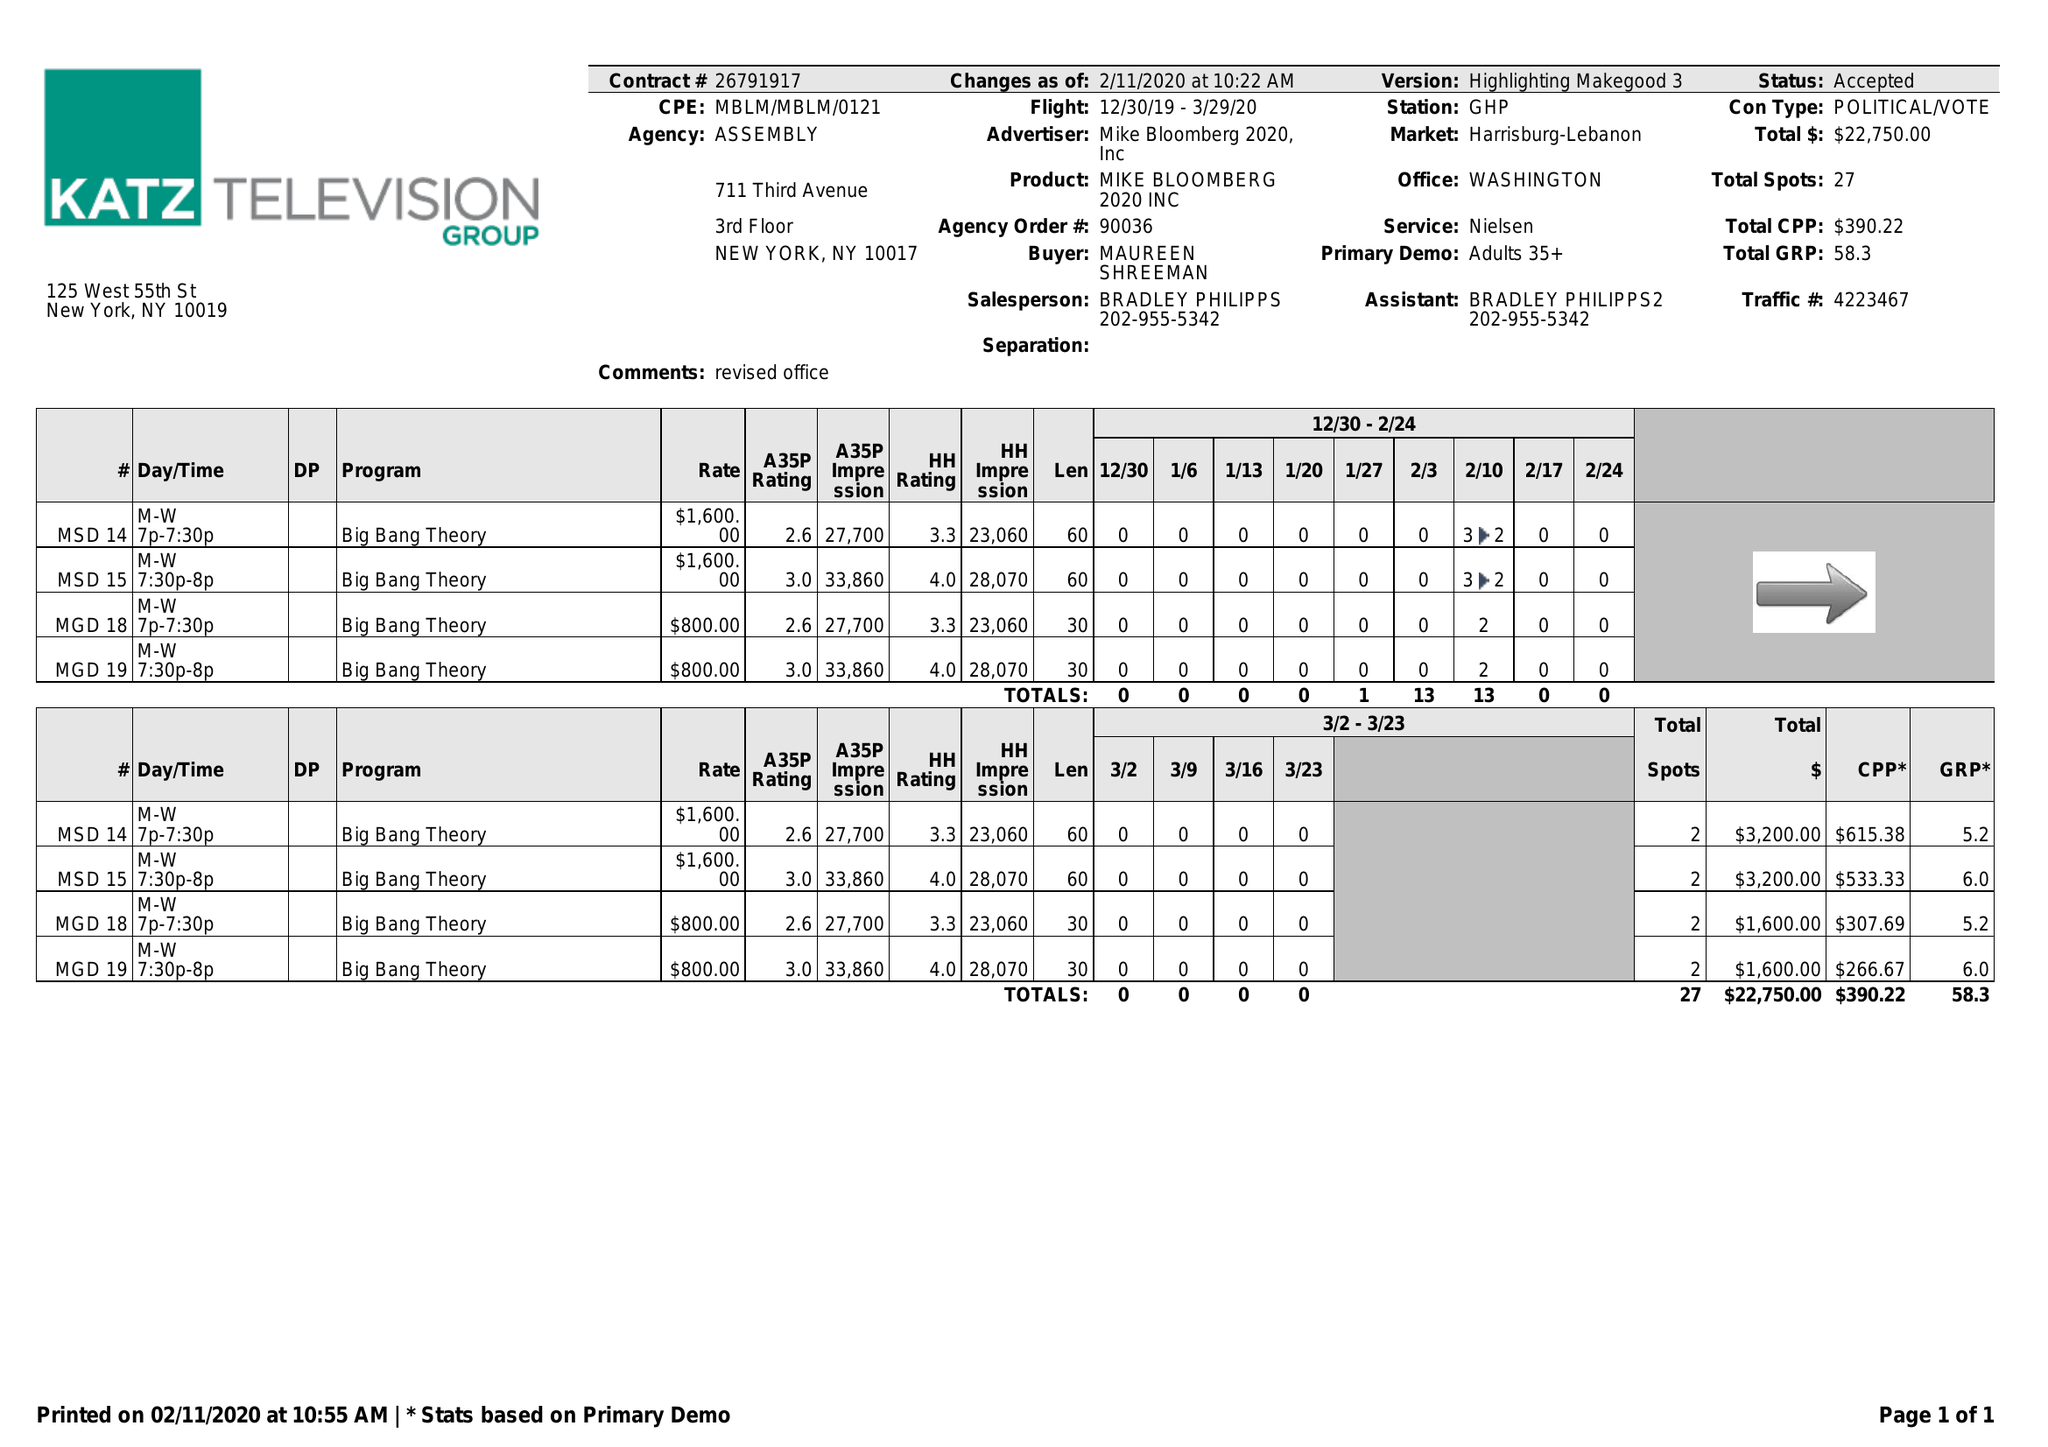What is the value for the flight_to?
Answer the question using a single word or phrase. 03/29/20 